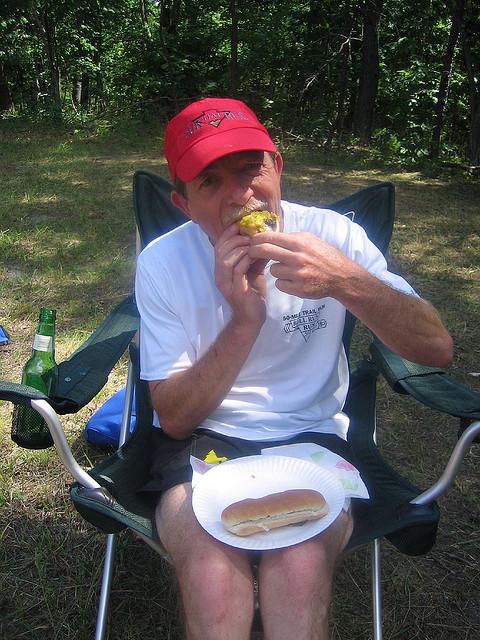What color is his hat?
Be succinct. Red. What is he eating?
Give a very brief answer. Hot dog. What is in the bottle?
Short answer required. Beer. 